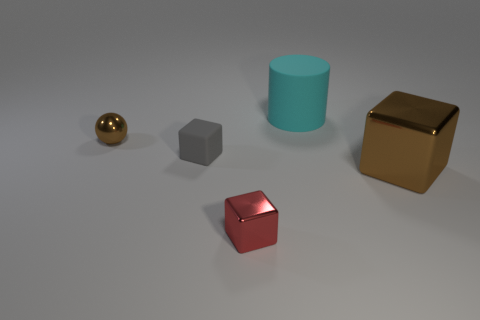There is a gray object that is the same shape as the red object; what is its size?
Your answer should be compact. Small. There is a metallic thing that is behind the tiny rubber cube; is its color the same as the large block?
Your answer should be very brief. Yes. What is the color of the tiny metal object that is the same shape as the big brown shiny object?
Provide a succinct answer. Red. What is the material of the large object behind the gray rubber object?
Ensure brevity in your answer.  Rubber. The small matte cube is what color?
Offer a terse response. Gray. There is a thing that is right of the cyan rubber cylinder; is its size the same as the cyan cylinder?
Make the answer very short. Yes. What material is the large object that is behind the tiny shiny ball in front of the rubber object on the right side of the tiny gray matte cube?
Make the answer very short. Rubber. There is a shiny object that is to the right of the large cyan object; does it have the same color as the small cube right of the small matte cube?
Offer a terse response. No. What is the material of the big thing behind the tiny metal sphere in front of the cyan thing?
Give a very brief answer. Rubber. There is another metal object that is the same size as the cyan thing; what color is it?
Your response must be concise. Brown. 